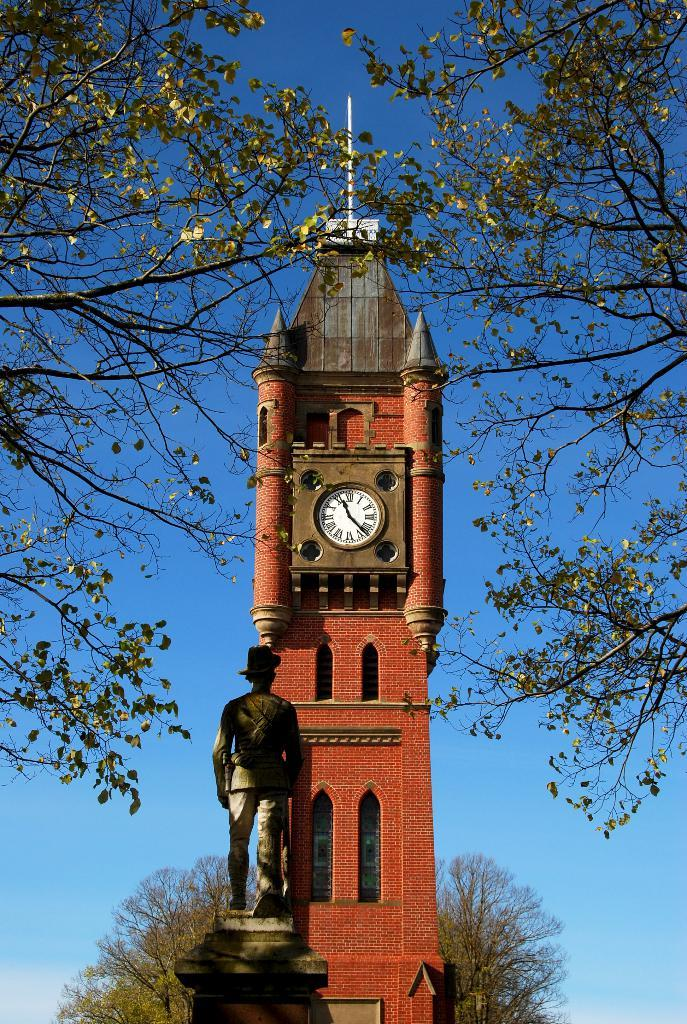<image>
Summarize the visual content of the image. A statue is in front of a brick clock tower showing the time 11:26. 